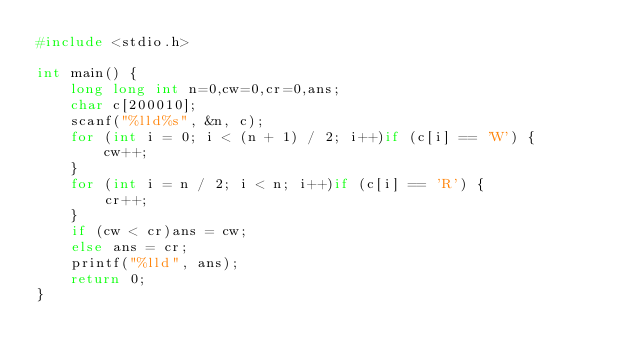Convert code to text. <code><loc_0><loc_0><loc_500><loc_500><_C_>#include <stdio.h>

int main() {
	long long int n=0,cw=0,cr=0,ans;
	char c[200010];
	scanf("%lld%s", &n, c);
	for (int i = 0; i < (n + 1) / 2; i++)if (c[i] == 'W') {
		cw++;
	}
	for (int i = n / 2; i < n; i++)if (c[i] == 'R') {
		cr++;
	}
	if (cw < cr)ans = cw;
	else ans = cr;
	printf("%lld", ans);
	return 0;
}</code> 